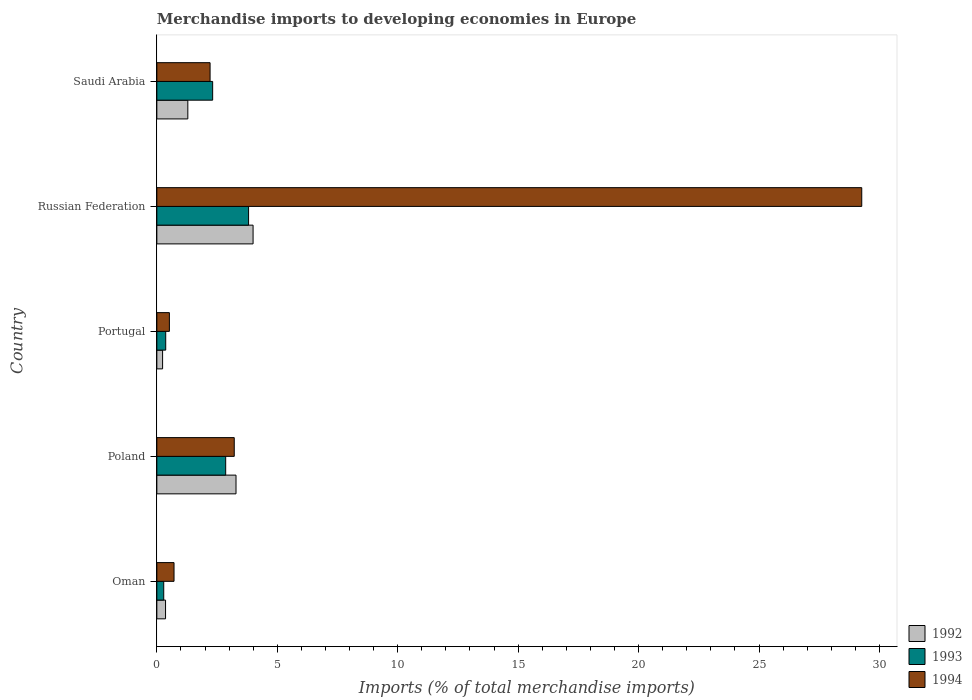Are the number of bars on each tick of the Y-axis equal?
Offer a terse response. Yes. What is the label of the 2nd group of bars from the top?
Provide a succinct answer. Russian Federation. What is the percentage total merchandise imports in 1993 in Portugal?
Your answer should be compact. 0.37. Across all countries, what is the maximum percentage total merchandise imports in 1992?
Offer a very short reply. 4. Across all countries, what is the minimum percentage total merchandise imports in 1992?
Make the answer very short. 0.24. In which country was the percentage total merchandise imports in 1994 maximum?
Make the answer very short. Russian Federation. What is the total percentage total merchandise imports in 1993 in the graph?
Offer a terse response. 9.64. What is the difference between the percentage total merchandise imports in 1992 in Poland and that in Russian Federation?
Give a very brief answer. -0.71. What is the difference between the percentage total merchandise imports in 1993 in Poland and the percentage total merchandise imports in 1994 in Oman?
Provide a short and direct response. 2.14. What is the average percentage total merchandise imports in 1994 per country?
Offer a terse response. 7.18. What is the difference between the percentage total merchandise imports in 1994 and percentage total merchandise imports in 1993 in Poland?
Offer a very short reply. 0.36. In how many countries, is the percentage total merchandise imports in 1993 greater than 11 %?
Provide a short and direct response. 0. What is the ratio of the percentage total merchandise imports in 1994 in Oman to that in Portugal?
Keep it short and to the point. 1.37. Is the difference between the percentage total merchandise imports in 1994 in Oman and Saudi Arabia greater than the difference between the percentage total merchandise imports in 1993 in Oman and Saudi Arabia?
Your answer should be very brief. Yes. What is the difference between the highest and the second highest percentage total merchandise imports in 1994?
Give a very brief answer. 26.05. What is the difference between the highest and the lowest percentage total merchandise imports in 1993?
Offer a terse response. 3.52. In how many countries, is the percentage total merchandise imports in 1992 greater than the average percentage total merchandise imports in 1992 taken over all countries?
Provide a succinct answer. 2. What does the 1st bar from the bottom in Russian Federation represents?
Make the answer very short. 1992. Are all the bars in the graph horizontal?
Offer a terse response. Yes. What is the difference between two consecutive major ticks on the X-axis?
Ensure brevity in your answer.  5. Are the values on the major ticks of X-axis written in scientific E-notation?
Provide a short and direct response. No. Does the graph contain any zero values?
Make the answer very short. No. Does the graph contain grids?
Ensure brevity in your answer.  No. How many legend labels are there?
Offer a terse response. 3. What is the title of the graph?
Offer a very short reply. Merchandise imports to developing economies in Europe. What is the label or title of the X-axis?
Offer a very short reply. Imports (% of total merchandise imports). What is the Imports (% of total merchandise imports) in 1992 in Oman?
Ensure brevity in your answer.  0.36. What is the Imports (% of total merchandise imports) of 1993 in Oman?
Keep it short and to the point. 0.29. What is the Imports (% of total merchandise imports) of 1994 in Oman?
Keep it short and to the point. 0.71. What is the Imports (% of total merchandise imports) of 1992 in Poland?
Provide a short and direct response. 3.29. What is the Imports (% of total merchandise imports) of 1993 in Poland?
Your answer should be compact. 2.86. What is the Imports (% of total merchandise imports) of 1994 in Poland?
Your answer should be very brief. 3.21. What is the Imports (% of total merchandise imports) of 1992 in Portugal?
Provide a short and direct response. 0.24. What is the Imports (% of total merchandise imports) in 1993 in Portugal?
Offer a very short reply. 0.37. What is the Imports (% of total merchandise imports) in 1994 in Portugal?
Your answer should be very brief. 0.52. What is the Imports (% of total merchandise imports) in 1992 in Russian Federation?
Your answer should be very brief. 4. What is the Imports (% of total merchandise imports) in 1993 in Russian Federation?
Offer a very short reply. 3.81. What is the Imports (% of total merchandise imports) in 1994 in Russian Federation?
Ensure brevity in your answer.  29.26. What is the Imports (% of total merchandise imports) in 1992 in Saudi Arabia?
Give a very brief answer. 1.29. What is the Imports (% of total merchandise imports) of 1993 in Saudi Arabia?
Make the answer very short. 2.32. What is the Imports (% of total merchandise imports) in 1994 in Saudi Arabia?
Make the answer very short. 2.21. Across all countries, what is the maximum Imports (% of total merchandise imports) in 1992?
Ensure brevity in your answer.  4. Across all countries, what is the maximum Imports (% of total merchandise imports) of 1993?
Give a very brief answer. 3.81. Across all countries, what is the maximum Imports (% of total merchandise imports) of 1994?
Ensure brevity in your answer.  29.26. Across all countries, what is the minimum Imports (% of total merchandise imports) of 1992?
Offer a terse response. 0.24. Across all countries, what is the minimum Imports (% of total merchandise imports) in 1993?
Give a very brief answer. 0.29. Across all countries, what is the minimum Imports (% of total merchandise imports) in 1994?
Your answer should be very brief. 0.52. What is the total Imports (% of total merchandise imports) of 1992 in the graph?
Provide a succinct answer. 9.17. What is the total Imports (% of total merchandise imports) of 1993 in the graph?
Offer a very short reply. 9.64. What is the total Imports (% of total merchandise imports) of 1994 in the graph?
Offer a terse response. 35.92. What is the difference between the Imports (% of total merchandise imports) in 1992 in Oman and that in Poland?
Ensure brevity in your answer.  -2.93. What is the difference between the Imports (% of total merchandise imports) in 1993 in Oman and that in Poland?
Your response must be concise. -2.57. What is the difference between the Imports (% of total merchandise imports) of 1994 in Oman and that in Poland?
Your response must be concise. -2.5. What is the difference between the Imports (% of total merchandise imports) of 1992 in Oman and that in Portugal?
Your answer should be very brief. 0.12. What is the difference between the Imports (% of total merchandise imports) in 1993 in Oman and that in Portugal?
Ensure brevity in your answer.  -0.08. What is the difference between the Imports (% of total merchandise imports) in 1994 in Oman and that in Portugal?
Provide a short and direct response. 0.19. What is the difference between the Imports (% of total merchandise imports) in 1992 in Oman and that in Russian Federation?
Offer a terse response. -3.63. What is the difference between the Imports (% of total merchandise imports) of 1993 in Oman and that in Russian Federation?
Provide a short and direct response. -3.52. What is the difference between the Imports (% of total merchandise imports) in 1994 in Oman and that in Russian Federation?
Ensure brevity in your answer.  -28.55. What is the difference between the Imports (% of total merchandise imports) in 1992 in Oman and that in Saudi Arabia?
Keep it short and to the point. -0.92. What is the difference between the Imports (% of total merchandise imports) of 1993 in Oman and that in Saudi Arabia?
Your answer should be very brief. -2.03. What is the difference between the Imports (% of total merchandise imports) in 1994 in Oman and that in Saudi Arabia?
Ensure brevity in your answer.  -1.5. What is the difference between the Imports (% of total merchandise imports) of 1992 in Poland and that in Portugal?
Your answer should be very brief. 3.05. What is the difference between the Imports (% of total merchandise imports) in 1993 in Poland and that in Portugal?
Ensure brevity in your answer.  2.49. What is the difference between the Imports (% of total merchandise imports) in 1994 in Poland and that in Portugal?
Make the answer very short. 2.69. What is the difference between the Imports (% of total merchandise imports) of 1992 in Poland and that in Russian Federation?
Make the answer very short. -0.71. What is the difference between the Imports (% of total merchandise imports) in 1993 in Poland and that in Russian Federation?
Ensure brevity in your answer.  -0.95. What is the difference between the Imports (% of total merchandise imports) of 1994 in Poland and that in Russian Federation?
Keep it short and to the point. -26.05. What is the difference between the Imports (% of total merchandise imports) of 1992 in Poland and that in Saudi Arabia?
Keep it short and to the point. 2. What is the difference between the Imports (% of total merchandise imports) in 1993 in Poland and that in Saudi Arabia?
Provide a short and direct response. 0.54. What is the difference between the Imports (% of total merchandise imports) of 1992 in Portugal and that in Russian Federation?
Offer a very short reply. -3.76. What is the difference between the Imports (% of total merchandise imports) in 1993 in Portugal and that in Russian Federation?
Your response must be concise. -3.44. What is the difference between the Imports (% of total merchandise imports) in 1994 in Portugal and that in Russian Federation?
Keep it short and to the point. -28.74. What is the difference between the Imports (% of total merchandise imports) of 1992 in Portugal and that in Saudi Arabia?
Your response must be concise. -1.05. What is the difference between the Imports (% of total merchandise imports) in 1993 in Portugal and that in Saudi Arabia?
Offer a terse response. -1.95. What is the difference between the Imports (% of total merchandise imports) in 1994 in Portugal and that in Saudi Arabia?
Your answer should be very brief. -1.69. What is the difference between the Imports (% of total merchandise imports) in 1992 in Russian Federation and that in Saudi Arabia?
Your answer should be very brief. 2.71. What is the difference between the Imports (% of total merchandise imports) in 1993 in Russian Federation and that in Saudi Arabia?
Ensure brevity in your answer.  1.49. What is the difference between the Imports (% of total merchandise imports) of 1994 in Russian Federation and that in Saudi Arabia?
Make the answer very short. 27.05. What is the difference between the Imports (% of total merchandise imports) in 1992 in Oman and the Imports (% of total merchandise imports) in 1993 in Poland?
Ensure brevity in your answer.  -2.5. What is the difference between the Imports (% of total merchandise imports) in 1992 in Oman and the Imports (% of total merchandise imports) in 1994 in Poland?
Your answer should be compact. -2.85. What is the difference between the Imports (% of total merchandise imports) in 1993 in Oman and the Imports (% of total merchandise imports) in 1994 in Poland?
Your answer should be very brief. -2.93. What is the difference between the Imports (% of total merchandise imports) of 1992 in Oman and the Imports (% of total merchandise imports) of 1993 in Portugal?
Ensure brevity in your answer.  -0.01. What is the difference between the Imports (% of total merchandise imports) in 1992 in Oman and the Imports (% of total merchandise imports) in 1994 in Portugal?
Your answer should be compact. -0.16. What is the difference between the Imports (% of total merchandise imports) of 1993 in Oman and the Imports (% of total merchandise imports) of 1994 in Portugal?
Your answer should be very brief. -0.23. What is the difference between the Imports (% of total merchandise imports) in 1992 in Oman and the Imports (% of total merchandise imports) in 1993 in Russian Federation?
Provide a short and direct response. -3.45. What is the difference between the Imports (% of total merchandise imports) of 1992 in Oman and the Imports (% of total merchandise imports) of 1994 in Russian Federation?
Your answer should be compact. -28.9. What is the difference between the Imports (% of total merchandise imports) of 1993 in Oman and the Imports (% of total merchandise imports) of 1994 in Russian Federation?
Keep it short and to the point. -28.98. What is the difference between the Imports (% of total merchandise imports) of 1992 in Oman and the Imports (% of total merchandise imports) of 1993 in Saudi Arabia?
Provide a succinct answer. -1.96. What is the difference between the Imports (% of total merchandise imports) of 1992 in Oman and the Imports (% of total merchandise imports) of 1994 in Saudi Arabia?
Offer a terse response. -1.85. What is the difference between the Imports (% of total merchandise imports) in 1993 in Oman and the Imports (% of total merchandise imports) in 1994 in Saudi Arabia?
Provide a short and direct response. -1.92. What is the difference between the Imports (% of total merchandise imports) in 1992 in Poland and the Imports (% of total merchandise imports) in 1993 in Portugal?
Provide a short and direct response. 2.92. What is the difference between the Imports (% of total merchandise imports) of 1992 in Poland and the Imports (% of total merchandise imports) of 1994 in Portugal?
Give a very brief answer. 2.77. What is the difference between the Imports (% of total merchandise imports) of 1993 in Poland and the Imports (% of total merchandise imports) of 1994 in Portugal?
Your answer should be very brief. 2.34. What is the difference between the Imports (% of total merchandise imports) in 1992 in Poland and the Imports (% of total merchandise imports) in 1993 in Russian Federation?
Your answer should be very brief. -0.52. What is the difference between the Imports (% of total merchandise imports) in 1992 in Poland and the Imports (% of total merchandise imports) in 1994 in Russian Federation?
Your response must be concise. -25.98. What is the difference between the Imports (% of total merchandise imports) in 1993 in Poland and the Imports (% of total merchandise imports) in 1994 in Russian Federation?
Make the answer very short. -26.41. What is the difference between the Imports (% of total merchandise imports) of 1992 in Poland and the Imports (% of total merchandise imports) of 1993 in Saudi Arabia?
Provide a short and direct response. 0.97. What is the difference between the Imports (% of total merchandise imports) in 1992 in Poland and the Imports (% of total merchandise imports) in 1994 in Saudi Arabia?
Your answer should be compact. 1.08. What is the difference between the Imports (% of total merchandise imports) of 1993 in Poland and the Imports (% of total merchandise imports) of 1994 in Saudi Arabia?
Your answer should be compact. 0.65. What is the difference between the Imports (% of total merchandise imports) in 1992 in Portugal and the Imports (% of total merchandise imports) in 1993 in Russian Federation?
Offer a terse response. -3.57. What is the difference between the Imports (% of total merchandise imports) in 1992 in Portugal and the Imports (% of total merchandise imports) in 1994 in Russian Federation?
Your answer should be very brief. -29.03. What is the difference between the Imports (% of total merchandise imports) in 1993 in Portugal and the Imports (% of total merchandise imports) in 1994 in Russian Federation?
Your response must be concise. -28.9. What is the difference between the Imports (% of total merchandise imports) in 1992 in Portugal and the Imports (% of total merchandise imports) in 1993 in Saudi Arabia?
Your response must be concise. -2.08. What is the difference between the Imports (% of total merchandise imports) in 1992 in Portugal and the Imports (% of total merchandise imports) in 1994 in Saudi Arabia?
Ensure brevity in your answer.  -1.97. What is the difference between the Imports (% of total merchandise imports) in 1993 in Portugal and the Imports (% of total merchandise imports) in 1994 in Saudi Arabia?
Provide a short and direct response. -1.84. What is the difference between the Imports (% of total merchandise imports) in 1992 in Russian Federation and the Imports (% of total merchandise imports) in 1993 in Saudi Arabia?
Keep it short and to the point. 1.68. What is the difference between the Imports (% of total merchandise imports) in 1992 in Russian Federation and the Imports (% of total merchandise imports) in 1994 in Saudi Arabia?
Your answer should be compact. 1.79. What is the difference between the Imports (% of total merchandise imports) of 1993 in Russian Federation and the Imports (% of total merchandise imports) of 1994 in Saudi Arabia?
Offer a terse response. 1.6. What is the average Imports (% of total merchandise imports) in 1992 per country?
Keep it short and to the point. 1.83. What is the average Imports (% of total merchandise imports) of 1993 per country?
Make the answer very short. 1.93. What is the average Imports (% of total merchandise imports) of 1994 per country?
Provide a short and direct response. 7.18. What is the difference between the Imports (% of total merchandise imports) in 1992 and Imports (% of total merchandise imports) in 1993 in Oman?
Ensure brevity in your answer.  0.08. What is the difference between the Imports (% of total merchandise imports) of 1992 and Imports (% of total merchandise imports) of 1994 in Oman?
Provide a short and direct response. -0.35. What is the difference between the Imports (% of total merchandise imports) in 1993 and Imports (% of total merchandise imports) in 1994 in Oman?
Ensure brevity in your answer.  -0.43. What is the difference between the Imports (% of total merchandise imports) of 1992 and Imports (% of total merchandise imports) of 1993 in Poland?
Provide a succinct answer. 0.43. What is the difference between the Imports (% of total merchandise imports) in 1992 and Imports (% of total merchandise imports) in 1994 in Poland?
Make the answer very short. 0.07. What is the difference between the Imports (% of total merchandise imports) in 1993 and Imports (% of total merchandise imports) in 1994 in Poland?
Your answer should be compact. -0.36. What is the difference between the Imports (% of total merchandise imports) in 1992 and Imports (% of total merchandise imports) in 1993 in Portugal?
Give a very brief answer. -0.13. What is the difference between the Imports (% of total merchandise imports) of 1992 and Imports (% of total merchandise imports) of 1994 in Portugal?
Your answer should be very brief. -0.28. What is the difference between the Imports (% of total merchandise imports) of 1993 and Imports (% of total merchandise imports) of 1994 in Portugal?
Your answer should be compact. -0.15. What is the difference between the Imports (% of total merchandise imports) in 1992 and Imports (% of total merchandise imports) in 1993 in Russian Federation?
Ensure brevity in your answer.  0.19. What is the difference between the Imports (% of total merchandise imports) in 1992 and Imports (% of total merchandise imports) in 1994 in Russian Federation?
Your response must be concise. -25.27. What is the difference between the Imports (% of total merchandise imports) in 1993 and Imports (% of total merchandise imports) in 1994 in Russian Federation?
Offer a terse response. -25.46. What is the difference between the Imports (% of total merchandise imports) in 1992 and Imports (% of total merchandise imports) in 1993 in Saudi Arabia?
Make the answer very short. -1.03. What is the difference between the Imports (% of total merchandise imports) in 1992 and Imports (% of total merchandise imports) in 1994 in Saudi Arabia?
Offer a terse response. -0.92. What is the difference between the Imports (% of total merchandise imports) in 1993 and Imports (% of total merchandise imports) in 1994 in Saudi Arabia?
Give a very brief answer. 0.11. What is the ratio of the Imports (% of total merchandise imports) in 1992 in Oman to that in Poland?
Offer a terse response. 0.11. What is the ratio of the Imports (% of total merchandise imports) in 1993 in Oman to that in Poland?
Ensure brevity in your answer.  0.1. What is the ratio of the Imports (% of total merchandise imports) in 1994 in Oman to that in Poland?
Ensure brevity in your answer.  0.22. What is the ratio of the Imports (% of total merchandise imports) of 1992 in Oman to that in Portugal?
Your answer should be compact. 1.51. What is the ratio of the Imports (% of total merchandise imports) of 1993 in Oman to that in Portugal?
Ensure brevity in your answer.  0.78. What is the ratio of the Imports (% of total merchandise imports) of 1994 in Oman to that in Portugal?
Offer a very short reply. 1.37. What is the ratio of the Imports (% of total merchandise imports) in 1992 in Oman to that in Russian Federation?
Provide a short and direct response. 0.09. What is the ratio of the Imports (% of total merchandise imports) in 1993 in Oman to that in Russian Federation?
Make the answer very short. 0.08. What is the ratio of the Imports (% of total merchandise imports) of 1994 in Oman to that in Russian Federation?
Give a very brief answer. 0.02. What is the ratio of the Imports (% of total merchandise imports) in 1992 in Oman to that in Saudi Arabia?
Give a very brief answer. 0.28. What is the ratio of the Imports (% of total merchandise imports) in 1993 in Oman to that in Saudi Arabia?
Ensure brevity in your answer.  0.12. What is the ratio of the Imports (% of total merchandise imports) of 1994 in Oman to that in Saudi Arabia?
Offer a very short reply. 0.32. What is the ratio of the Imports (% of total merchandise imports) in 1992 in Poland to that in Portugal?
Offer a very short reply. 13.77. What is the ratio of the Imports (% of total merchandise imports) of 1993 in Poland to that in Portugal?
Keep it short and to the point. 7.76. What is the ratio of the Imports (% of total merchandise imports) of 1994 in Poland to that in Portugal?
Make the answer very short. 6.17. What is the ratio of the Imports (% of total merchandise imports) in 1992 in Poland to that in Russian Federation?
Make the answer very short. 0.82. What is the ratio of the Imports (% of total merchandise imports) of 1993 in Poland to that in Russian Federation?
Offer a very short reply. 0.75. What is the ratio of the Imports (% of total merchandise imports) in 1994 in Poland to that in Russian Federation?
Provide a succinct answer. 0.11. What is the ratio of the Imports (% of total merchandise imports) of 1992 in Poland to that in Saudi Arabia?
Keep it short and to the point. 2.56. What is the ratio of the Imports (% of total merchandise imports) of 1993 in Poland to that in Saudi Arabia?
Your answer should be very brief. 1.23. What is the ratio of the Imports (% of total merchandise imports) in 1994 in Poland to that in Saudi Arabia?
Your answer should be very brief. 1.45. What is the ratio of the Imports (% of total merchandise imports) of 1992 in Portugal to that in Russian Federation?
Provide a succinct answer. 0.06. What is the ratio of the Imports (% of total merchandise imports) of 1993 in Portugal to that in Russian Federation?
Give a very brief answer. 0.1. What is the ratio of the Imports (% of total merchandise imports) in 1994 in Portugal to that in Russian Federation?
Keep it short and to the point. 0.02. What is the ratio of the Imports (% of total merchandise imports) in 1992 in Portugal to that in Saudi Arabia?
Provide a succinct answer. 0.19. What is the ratio of the Imports (% of total merchandise imports) in 1993 in Portugal to that in Saudi Arabia?
Provide a short and direct response. 0.16. What is the ratio of the Imports (% of total merchandise imports) of 1994 in Portugal to that in Saudi Arabia?
Your response must be concise. 0.24. What is the ratio of the Imports (% of total merchandise imports) in 1992 in Russian Federation to that in Saudi Arabia?
Ensure brevity in your answer.  3.11. What is the ratio of the Imports (% of total merchandise imports) of 1993 in Russian Federation to that in Saudi Arabia?
Your answer should be compact. 1.64. What is the ratio of the Imports (% of total merchandise imports) in 1994 in Russian Federation to that in Saudi Arabia?
Ensure brevity in your answer.  13.24. What is the difference between the highest and the second highest Imports (% of total merchandise imports) of 1992?
Your response must be concise. 0.71. What is the difference between the highest and the second highest Imports (% of total merchandise imports) of 1993?
Keep it short and to the point. 0.95. What is the difference between the highest and the second highest Imports (% of total merchandise imports) in 1994?
Provide a short and direct response. 26.05. What is the difference between the highest and the lowest Imports (% of total merchandise imports) in 1992?
Offer a very short reply. 3.76. What is the difference between the highest and the lowest Imports (% of total merchandise imports) of 1993?
Offer a very short reply. 3.52. What is the difference between the highest and the lowest Imports (% of total merchandise imports) of 1994?
Offer a very short reply. 28.74. 